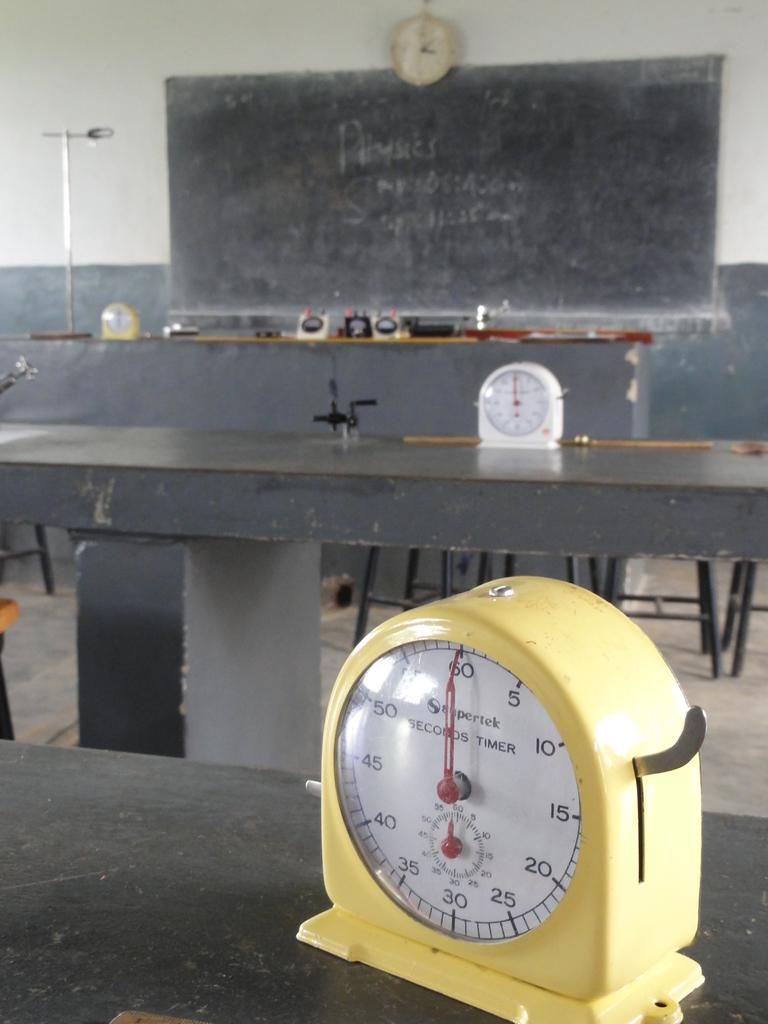<image>
Share a concise interpretation of the image provided. A blackboard in a classroom with the word physics written on it. 